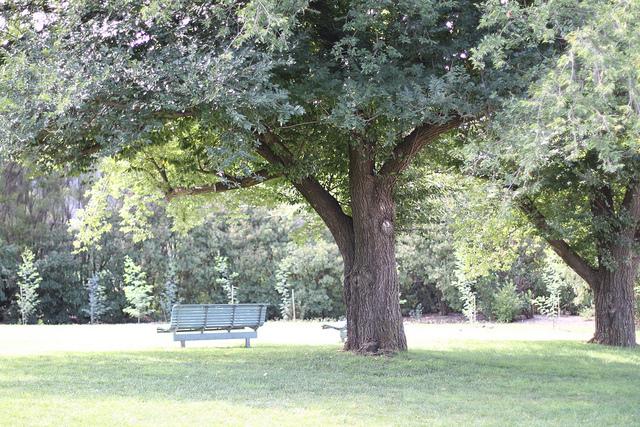What kind of the tree is there in the foreground?
Concise answer only. Oak. Is there a child under the tree?
Answer briefly. No. Is that a good tree for climbing?
Keep it brief. Yes. What color is the bench?
Concise answer only. Green. Is anyone sitting on the bench?
Concise answer only. No. 